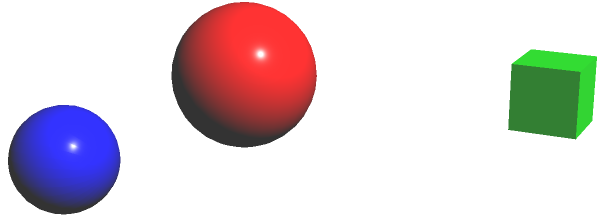Which two surfaces in the given set of 3D objects are homeomorphic to each other? To identify homeomorphic surfaces, we need to understand that homeomorphic objects can be continuously deformed into one another without cutting or gluing. Let's analyze each object:

1. Sphere: A closed surface with no holes.

2. Torus: A surface with one hole (like a donut).

3. Cube: Topologically equivalent to a sphere, as it can be continuously deformed into a sphere without cutting or gluing.

4. Klein bottle: A non-orientable surface with no boundary.

Step-by-step analysis:

1. The sphere and cube are homeomorphic:
   - The cube can be "inflated" to form a sphere without any cutting or gluing.
   - Both have no holes and are simply connected.

2. The torus is not homeomorphic to the sphere or cube:
   - It has one hole, which cannot be removed without cutting.

3. The Klein bottle is not homeomorphic to any of the other surfaces:
   - It's a non-orientable surface, unlike the others which are all orientable.
   - It cannot be embedded in 3D space without self-intersection.

4. The torus is not homeomorphic to the Klein bottle:
   - The torus is orientable, while the Klein bottle is not.
   - They have different Euler characteristics.

Therefore, the only pair of homeomorphic surfaces in this set is the sphere and the cube.
Answer: Sphere and cube 